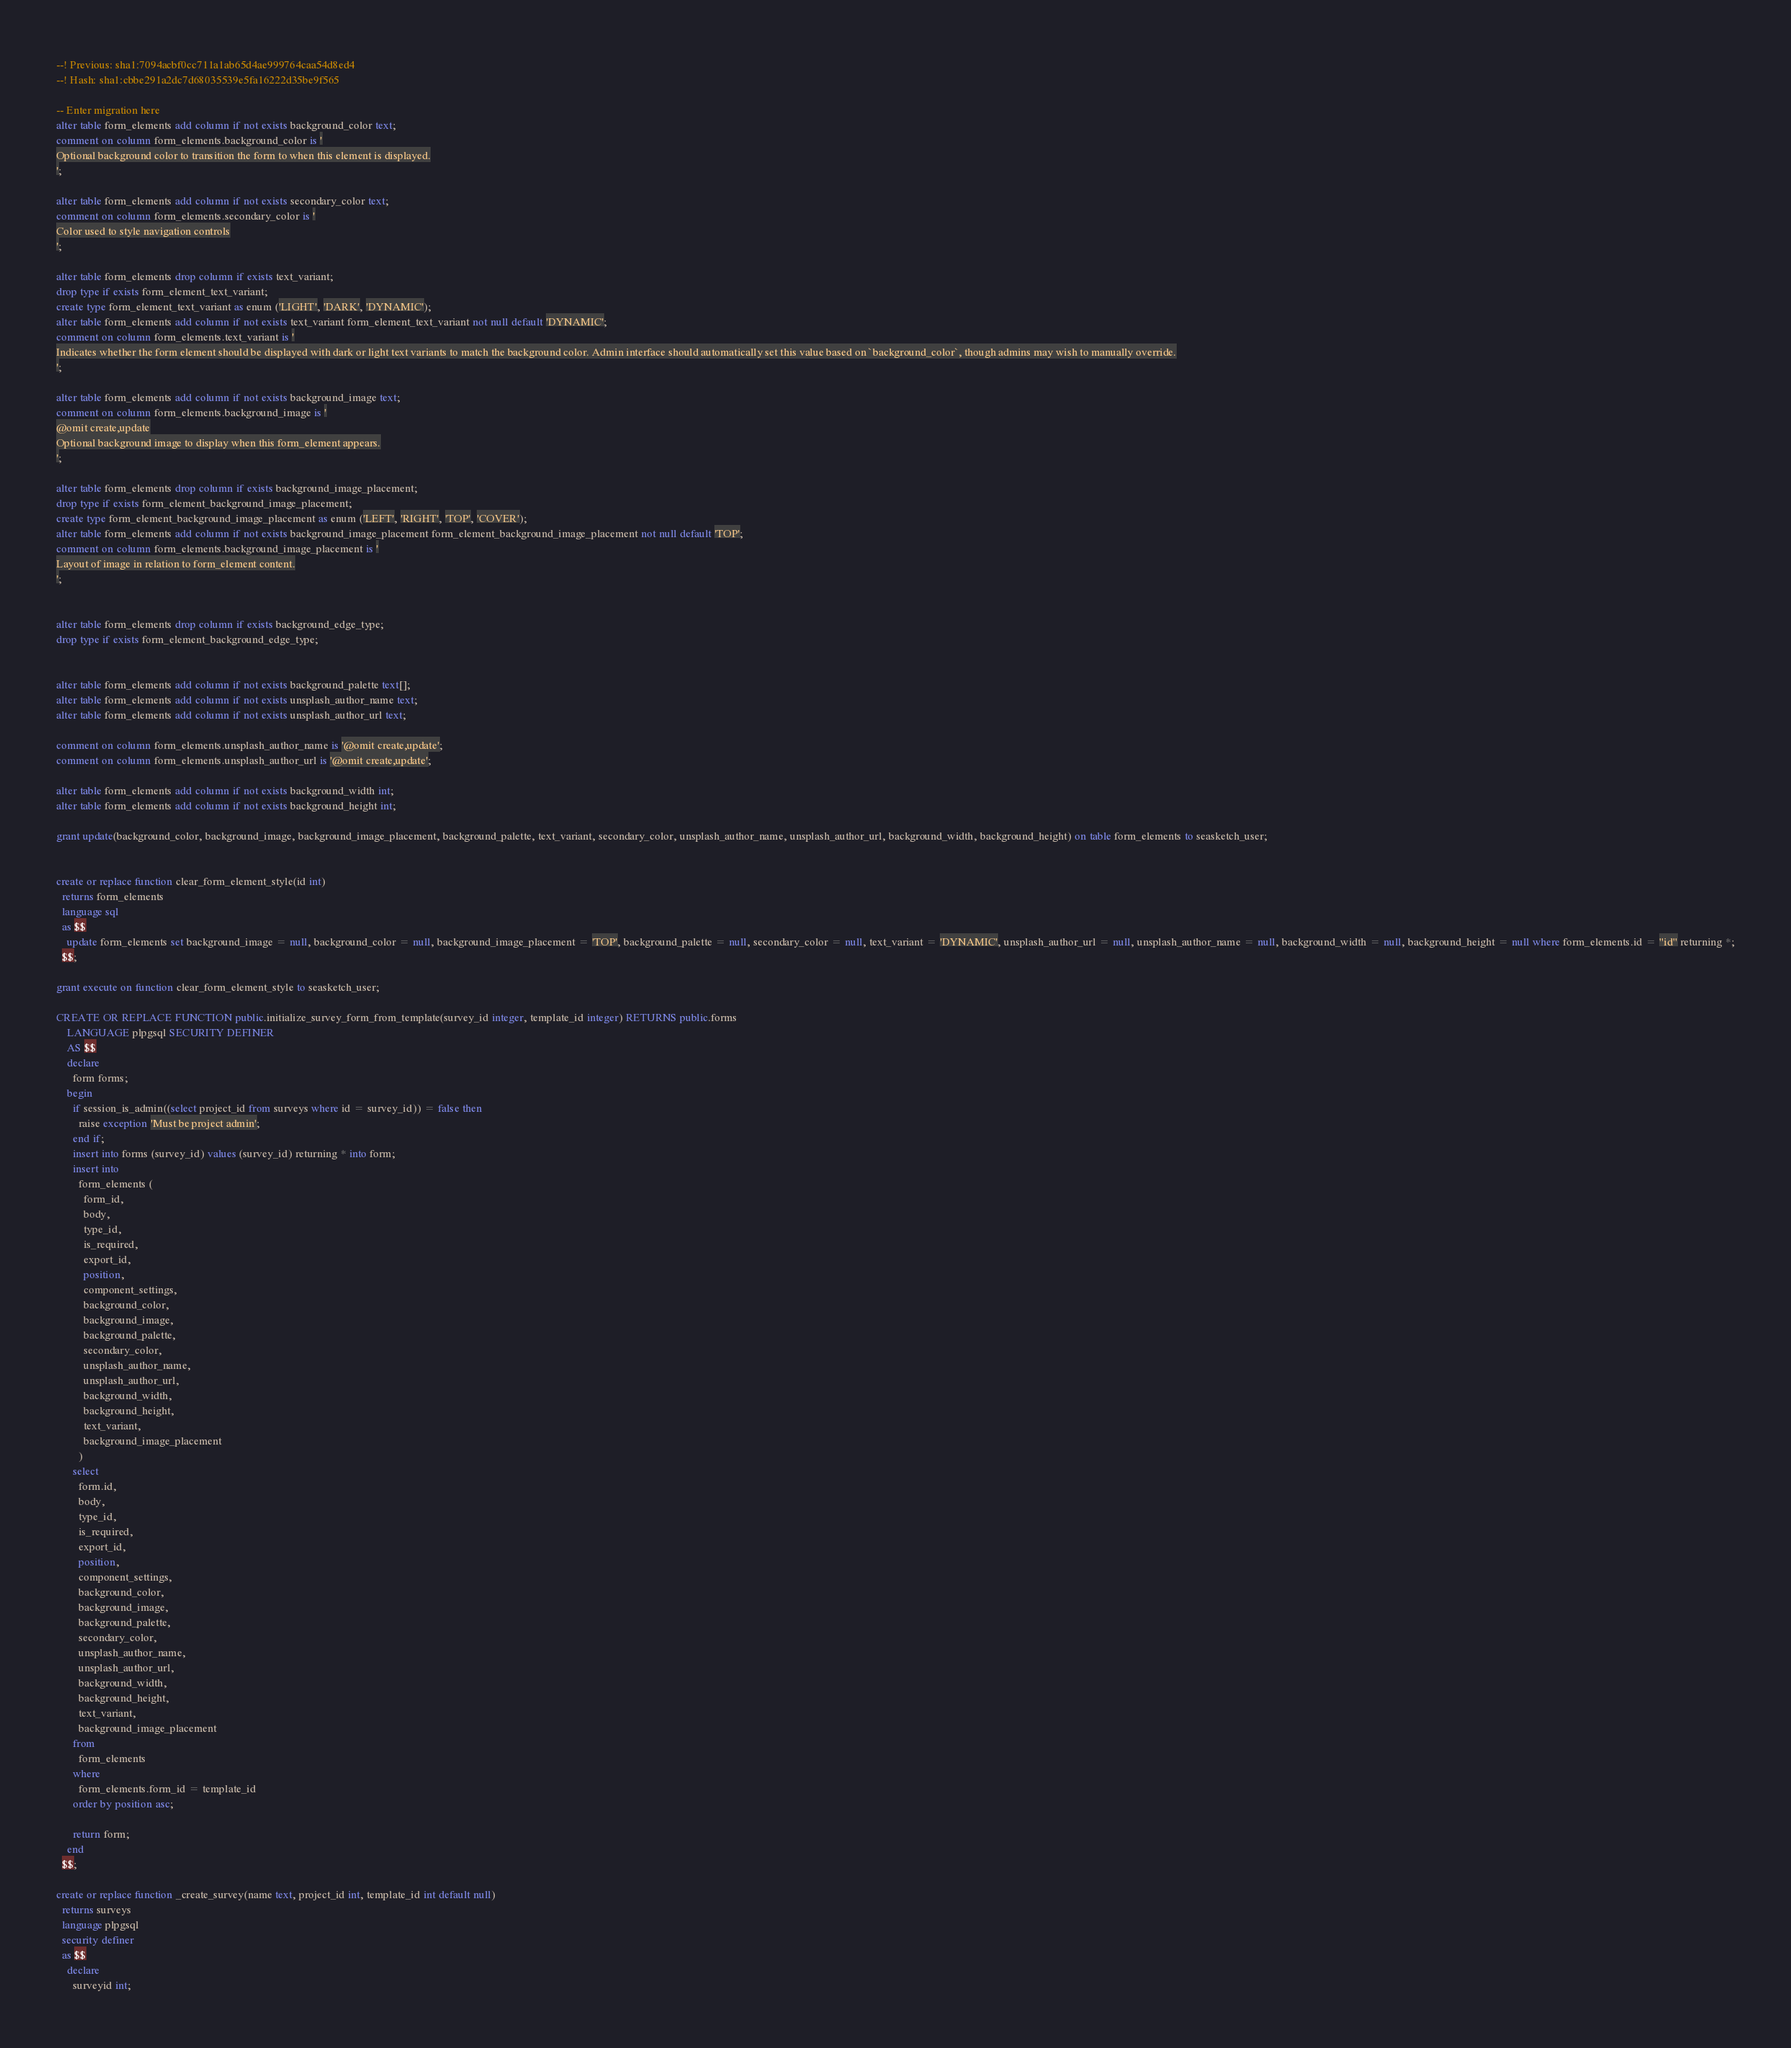Convert code to text. <code><loc_0><loc_0><loc_500><loc_500><_SQL_>--! Previous: sha1:7094acbf0cc711a1ab65d4ae999764caa54d8ed4
--! Hash: sha1:cbbe291a2dc7d68035539e5fa16222d35be9f565

-- Enter migration here
alter table form_elements add column if not exists background_color text;
comment on column form_elements.background_color is '
Optional background color to transition the form to when this element is displayed.
';

alter table form_elements add column if not exists secondary_color text;
comment on column form_elements.secondary_color is '
Color used to style navigation controls
';

alter table form_elements drop column if exists text_variant;
drop type if exists form_element_text_variant;
create type form_element_text_variant as enum ('LIGHT', 'DARK', 'DYNAMIC');
alter table form_elements add column if not exists text_variant form_element_text_variant not null default 'DYNAMIC';
comment on column form_elements.text_variant is '
Indicates whether the form element should be displayed with dark or light text variants to match the background color. Admin interface should automatically set this value based on `background_color`, though admins may wish to manually override.
';

alter table form_elements add column if not exists background_image text;
comment on column form_elements.background_image is '
@omit create,update
Optional background image to display when this form_element appears.
';

alter table form_elements drop column if exists background_image_placement;
drop type if exists form_element_background_image_placement;
create type form_element_background_image_placement as enum ('LEFT', 'RIGHT', 'TOP', 'COVER');
alter table form_elements add column if not exists background_image_placement form_element_background_image_placement not null default 'TOP';
comment on column form_elements.background_image_placement is '
Layout of image in relation to form_element content.
';


alter table form_elements drop column if exists background_edge_type;
drop type if exists form_element_background_edge_type;


alter table form_elements add column if not exists background_palette text[];
alter table form_elements add column if not exists unsplash_author_name text;
alter table form_elements add column if not exists unsplash_author_url text;

comment on column form_elements.unsplash_author_name is '@omit create,update';
comment on column form_elements.unsplash_author_url is '@omit create,update';

alter table form_elements add column if not exists background_width int;
alter table form_elements add column if not exists background_height int;

grant update(background_color, background_image, background_image_placement, background_palette, text_variant, secondary_color, unsplash_author_name, unsplash_author_url, background_width, background_height) on table form_elements to seasketch_user;


create or replace function clear_form_element_style(id int)
  returns form_elements
  language sql
  as $$
    update form_elements set background_image = null, background_color = null, background_image_placement = 'TOP', background_palette = null, secondary_color = null, text_variant = 'DYNAMIC', unsplash_author_url = null, unsplash_author_name = null, background_width = null, background_height = null where form_elements.id = "id" returning *;
  $$;

grant execute on function clear_form_element_style to seasketch_user;

CREATE OR REPLACE FUNCTION public.initialize_survey_form_from_template(survey_id integer, template_id integer) RETURNS public.forms
    LANGUAGE plpgsql SECURITY DEFINER
    AS $$
    declare
      form forms;
    begin
      if session_is_admin((select project_id from surveys where id = survey_id)) = false then
        raise exception 'Must be project admin';
      end if;
      insert into forms (survey_id) values (survey_id) returning * into form;
      insert into 
        form_elements (
          form_id, 
          body, 
          type_id, 
          is_required, 
          export_id, 
          position, 
          component_settings,
          background_color,   
          background_image,     
          background_palette,   
          secondary_color,      
          unsplash_author_name, 
          unsplash_author_url,  
          background_width,     
          background_height,    
          text_variant,
          background_image_placement
        )
      select 
        form.id, 
        body, 
        type_id, 
        is_required, 
        export_id, 
        position, 
        component_settings,
        background_color,     
        background_image,     
        background_palette,   
        secondary_color,      
        unsplash_author_name, 
        unsplash_author_url,  
        background_width,     
        background_height,    
        text_variant,
        background_image_placement
      from
        form_elements
      where
        form_elements.form_id = template_id
      order by position asc;
      
      return form;
    end
  $$;

create or replace function _create_survey(name text, project_id int, template_id int default null)
  returns surveys
  language plpgsql
  security definer
  as $$
    declare
      surveyid int;</code> 